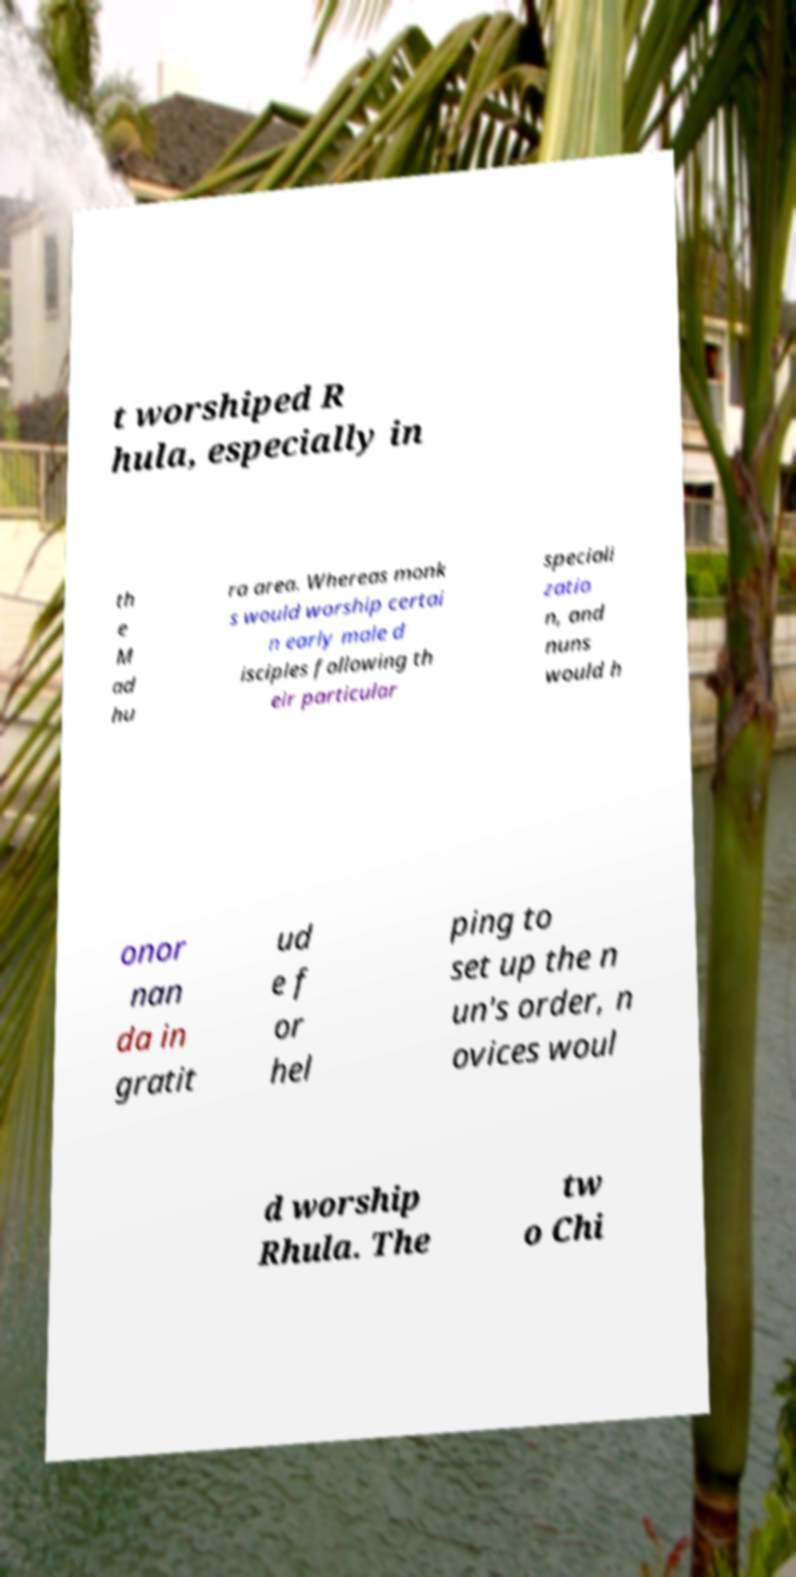Please identify and transcribe the text found in this image. t worshiped R hula, especially in th e M ad hu ra area. Whereas monk s would worship certai n early male d isciples following th eir particular speciali zatio n, and nuns would h onor nan da in gratit ud e f or hel ping to set up the n un's order, n ovices woul d worship Rhula. The tw o Chi 